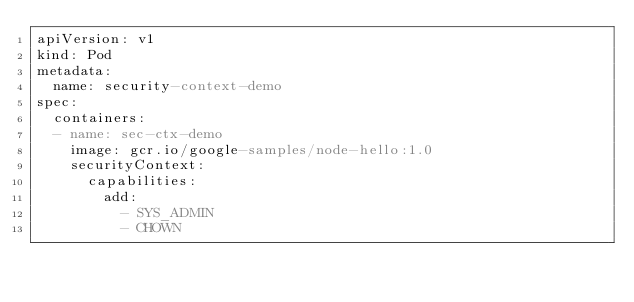Convert code to text. <code><loc_0><loc_0><loc_500><loc_500><_YAML_>apiVersion: v1
kind: Pod
metadata:
  name: security-context-demo
spec:
  containers:
  - name: sec-ctx-demo
    image: gcr.io/google-samples/node-hello:1.0
    securityContext:
      capabilities:
        add:
          - SYS_ADMIN
          - CHOWN
</code> 